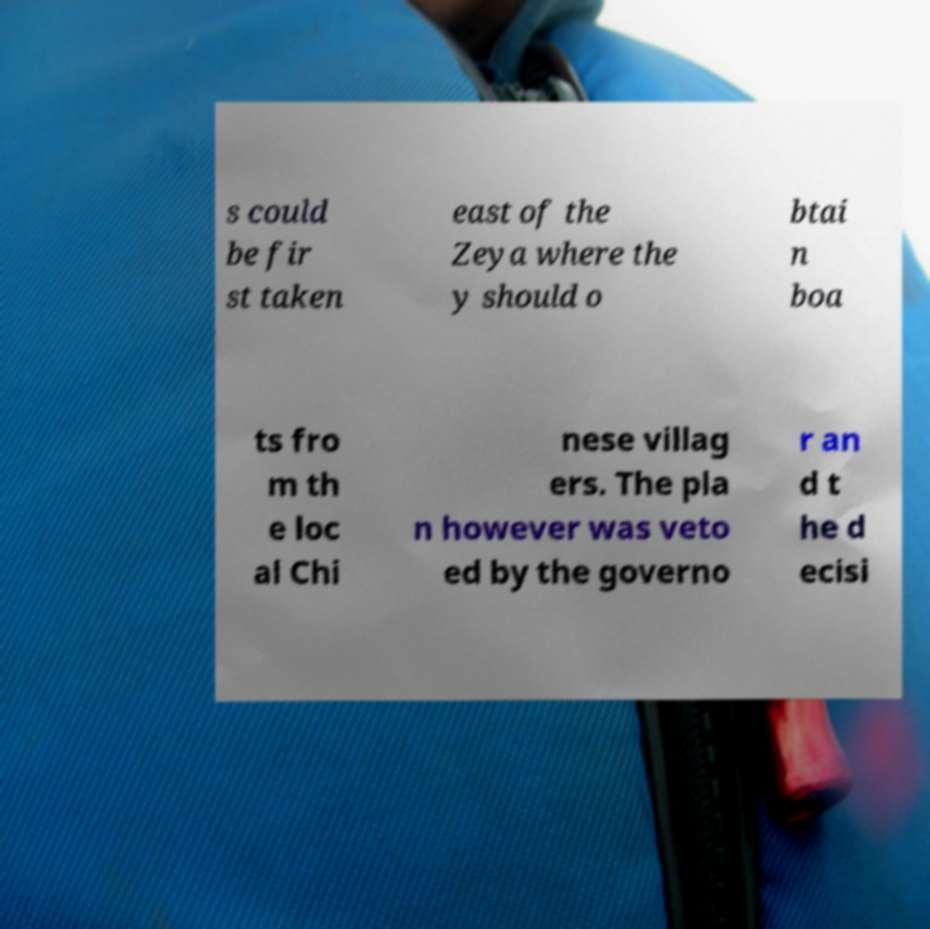Can you accurately transcribe the text from the provided image for me? s could be fir st taken east of the Zeya where the y should o btai n boa ts fro m th e loc al Chi nese villag ers. The pla n however was veto ed by the governo r an d t he d ecisi 